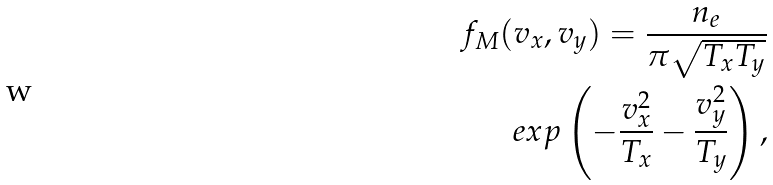Convert formula to latex. <formula><loc_0><loc_0><loc_500><loc_500>f _ { M } ( v _ { x } , v _ { y } ) = \frac { n _ { e } } { \pi \sqrt { T _ { x } T _ { y } } } \\ e x p \left ( - \frac { v _ { x } ^ { 2 } } { T _ { x } } - \frac { v _ { y } ^ { 2 } } { T _ { y } } \right ) ,</formula> 